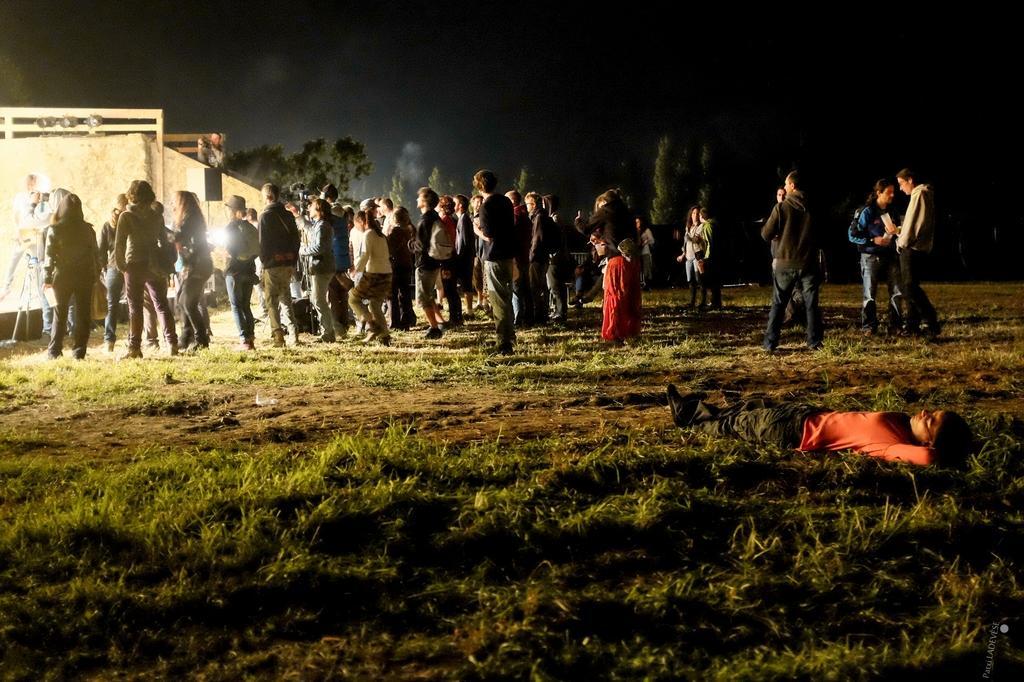Please provide a concise description of this image. In this picture, we can see there are groups of people standing and a person is lying on the grass. On the left side of the people there is a stand and some objects. Behind the people there are trees, smoke and the dark background. 